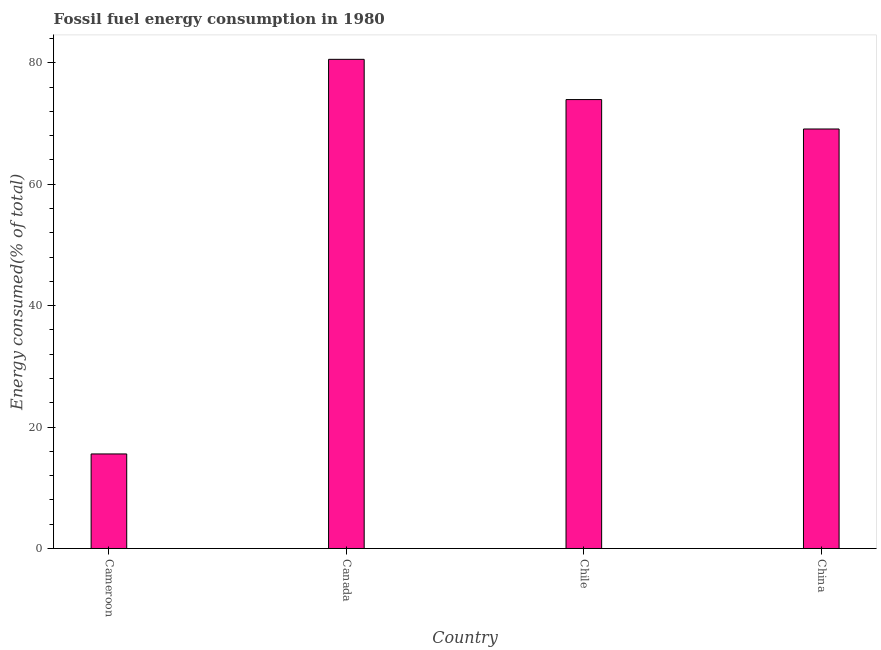Does the graph contain grids?
Your answer should be compact. No. What is the title of the graph?
Offer a terse response. Fossil fuel energy consumption in 1980. What is the label or title of the Y-axis?
Your answer should be compact. Energy consumed(% of total). What is the fossil fuel energy consumption in China?
Ensure brevity in your answer.  69.09. Across all countries, what is the maximum fossil fuel energy consumption?
Provide a short and direct response. 80.56. Across all countries, what is the minimum fossil fuel energy consumption?
Your answer should be compact. 15.57. In which country was the fossil fuel energy consumption minimum?
Keep it short and to the point. Cameroon. What is the sum of the fossil fuel energy consumption?
Keep it short and to the point. 239.17. What is the difference between the fossil fuel energy consumption in Cameroon and Canada?
Your answer should be very brief. -64.99. What is the average fossil fuel energy consumption per country?
Provide a succinct answer. 59.79. What is the median fossil fuel energy consumption?
Your answer should be very brief. 71.51. In how many countries, is the fossil fuel energy consumption greater than 44 %?
Offer a terse response. 3. What is the ratio of the fossil fuel energy consumption in Canada to that in Chile?
Offer a terse response. 1.09. What is the difference between the highest and the second highest fossil fuel energy consumption?
Your response must be concise. 6.63. Is the sum of the fossil fuel energy consumption in Chile and China greater than the maximum fossil fuel energy consumption across all countries?
Provide a short and direct response. Yes. What is the difference between the highest and the lowest fossil fuel energy consumption?
Offer a very short reply. 64.99. In how many countries, is the fossil fuel energy consumption greater than the average fossil fuel energy consumption taken over all countries?
Ensure brevity in your answer.  3. Are all the bars in the graph horizontal?
Keep it short and to the point. No. What is the difference between two consecutive major ticks on the Y-axis?
Give a very brief answer. 20. What is the Energy consumed(% of total) in Cameroon?
Your answer should be very brief. 15.57. What is the Energy consumed(% of total) of Canada?
Provide a short and direct response. 80.56. What is the Energy consumed(% of total) in Chile?
Offer a terse response. 73.94. What is the Energy consumed(% of total) in China?
Offer a very short reply. 69.09. What is the difference between the Energy consumed(% of total) in Cameroon and Canada?
Offer a very short reply. -64.99. What is the difference between the Energy consumed(% of total) in Cameroon and Chile?
Make the answer very short. -58.37. What is the difference between the Energy consumed(% of total) in Cameroon and China?
Offer a terse response. -53.52. What is the difference between the Energy consumed(% of total) in Canada and Chile?
Offer a terse response. 6.63. What is the difference between the Energy consumed(% of total) in Canada and China?
Offer a very short reply. 11.47. What is the difference between the Energy consumed(% of total) in Chile and China?
Your answer should be very brief. 4.85. What is the ratio of the Energy consumed(% of total) in Cameroon to that in Canada?
Give a very brief answer. 0.19. What is the ratio of the Energy consumed(% of total) in Cameroon to that in Chile?
Your answer should be compact. 0.21. What is the ratio of the Energy consumed(% of total) in Cameroon to that in China?
Provide a succinct answer. 0.23. What is the ratio of the Energy consumed(% of total) in Canada to that in Chile?
Offer a very short reply. 1.09. What is the ratio of the Energy consumed(% of total) in Canada to that in China?
Provide a short and direct response. 1.17. What is the ratio of the Energy consumed(% of total) in Chile to that in China?
Make the answer very short. 1.07. 